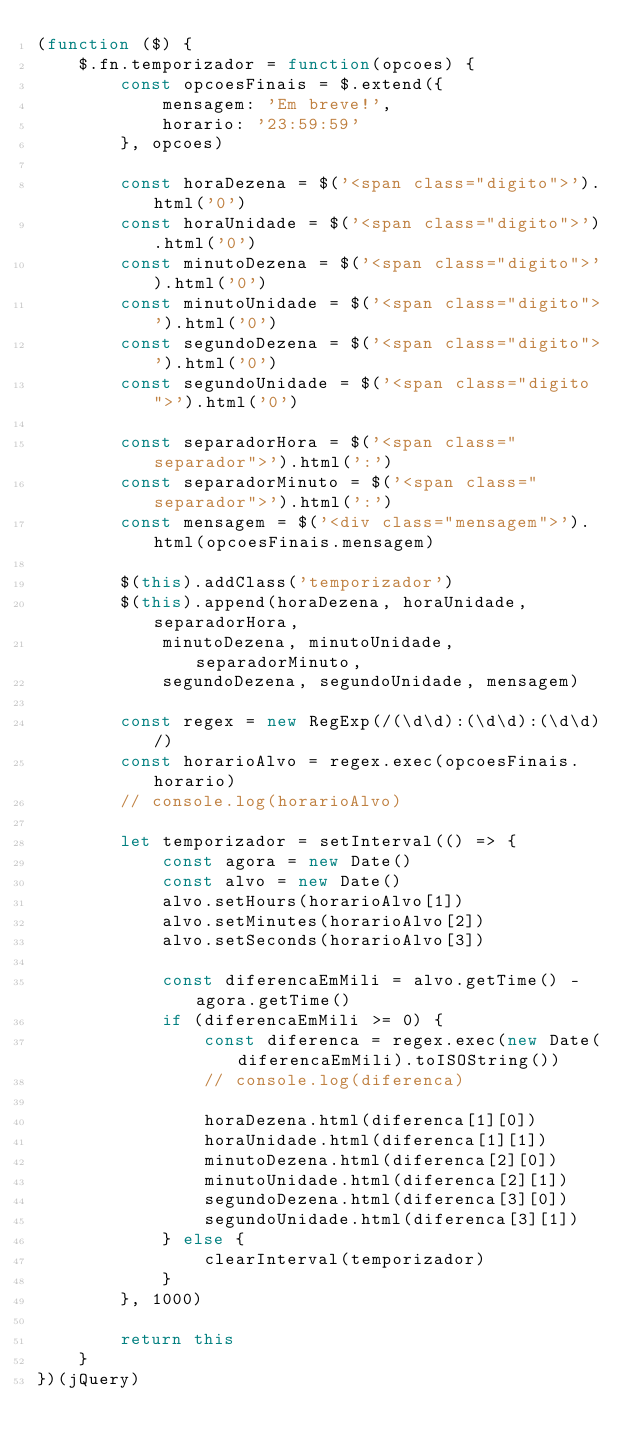Convert code to text. <code><loc_0><loc_0><loc_500><loc_500><_JavaScript_>(function ($) {
    $.fn.temporizador = function(opcoes) {
        const opcoesFinais = $.extend({
            mensagem: 'Em breve!',
            horario: '23:59:59'
        }, opcoes)

        const horaDezena = $('<span class="digito">').html('0')
        const horaUnidade = $('<span class="digito">').html('0')
        const minutoDezena = $('<span class="digito">').html('0')
        const minutoUnidade = $('<span class="digito">').html('0')
        const segundoDezena = $('<span class="digito">').html('0')
        const segundoUnidade = $('<span class="digito">').html('0')

        const separadorHora = $('<span class="separador">').html(':')
        const separadorMinuto = $('<span class="separador">').html(':')
        const mensagem = $('<div class="mensagem">').html(opcoesFinais.mensagem)

        $(this).addClass('temporizador')
        $(this).append(horaDezena, horaUnidade, separadorHora,
            minutoDezena, minutoUnidade, separadorMinuto,
            segundoDezena, segundoUnidade, mensagem)

        const regex = new RegExp(/(\d\d):(\d\d):(\d\d)/)
        const horarioAlvo = regex.exec(opcoesFinais.horario)
        // console.log(horarioAlvo)

        let temporizador = setInterval(() => {
            const agora = new Date()
            const alvo = new Date()
            alvo.setHours(horarioAlvo[1])
            alvo.setMinutes(horarioAlvo[2])
            alvo.setSeconds(horarioAlvo[3])

            const diferencaEmMili = alvo.getTime() - agora.getTime()
            if (diferencaEmMili >= 0) {
                const diferenca = regex.exec(new Date(diferencaEmMili).toISOString())
                // console.log(diferenca)

                horaDezena.html(diferenca[1][0])
                horaUnidade.html(diferenca[1][1])
                minutoDezena.html(diferenca[2][0])
                minutoUnidade.html(diferenca[2][1])
                segundoDezena.html(diferenca[3][0])
                segundoUnidade.html(diferenca[3][1])
            } else {
                clearInterval(temporizador)
            }
        }, 1000)

        return this
    }
})(jQuery)</code> 